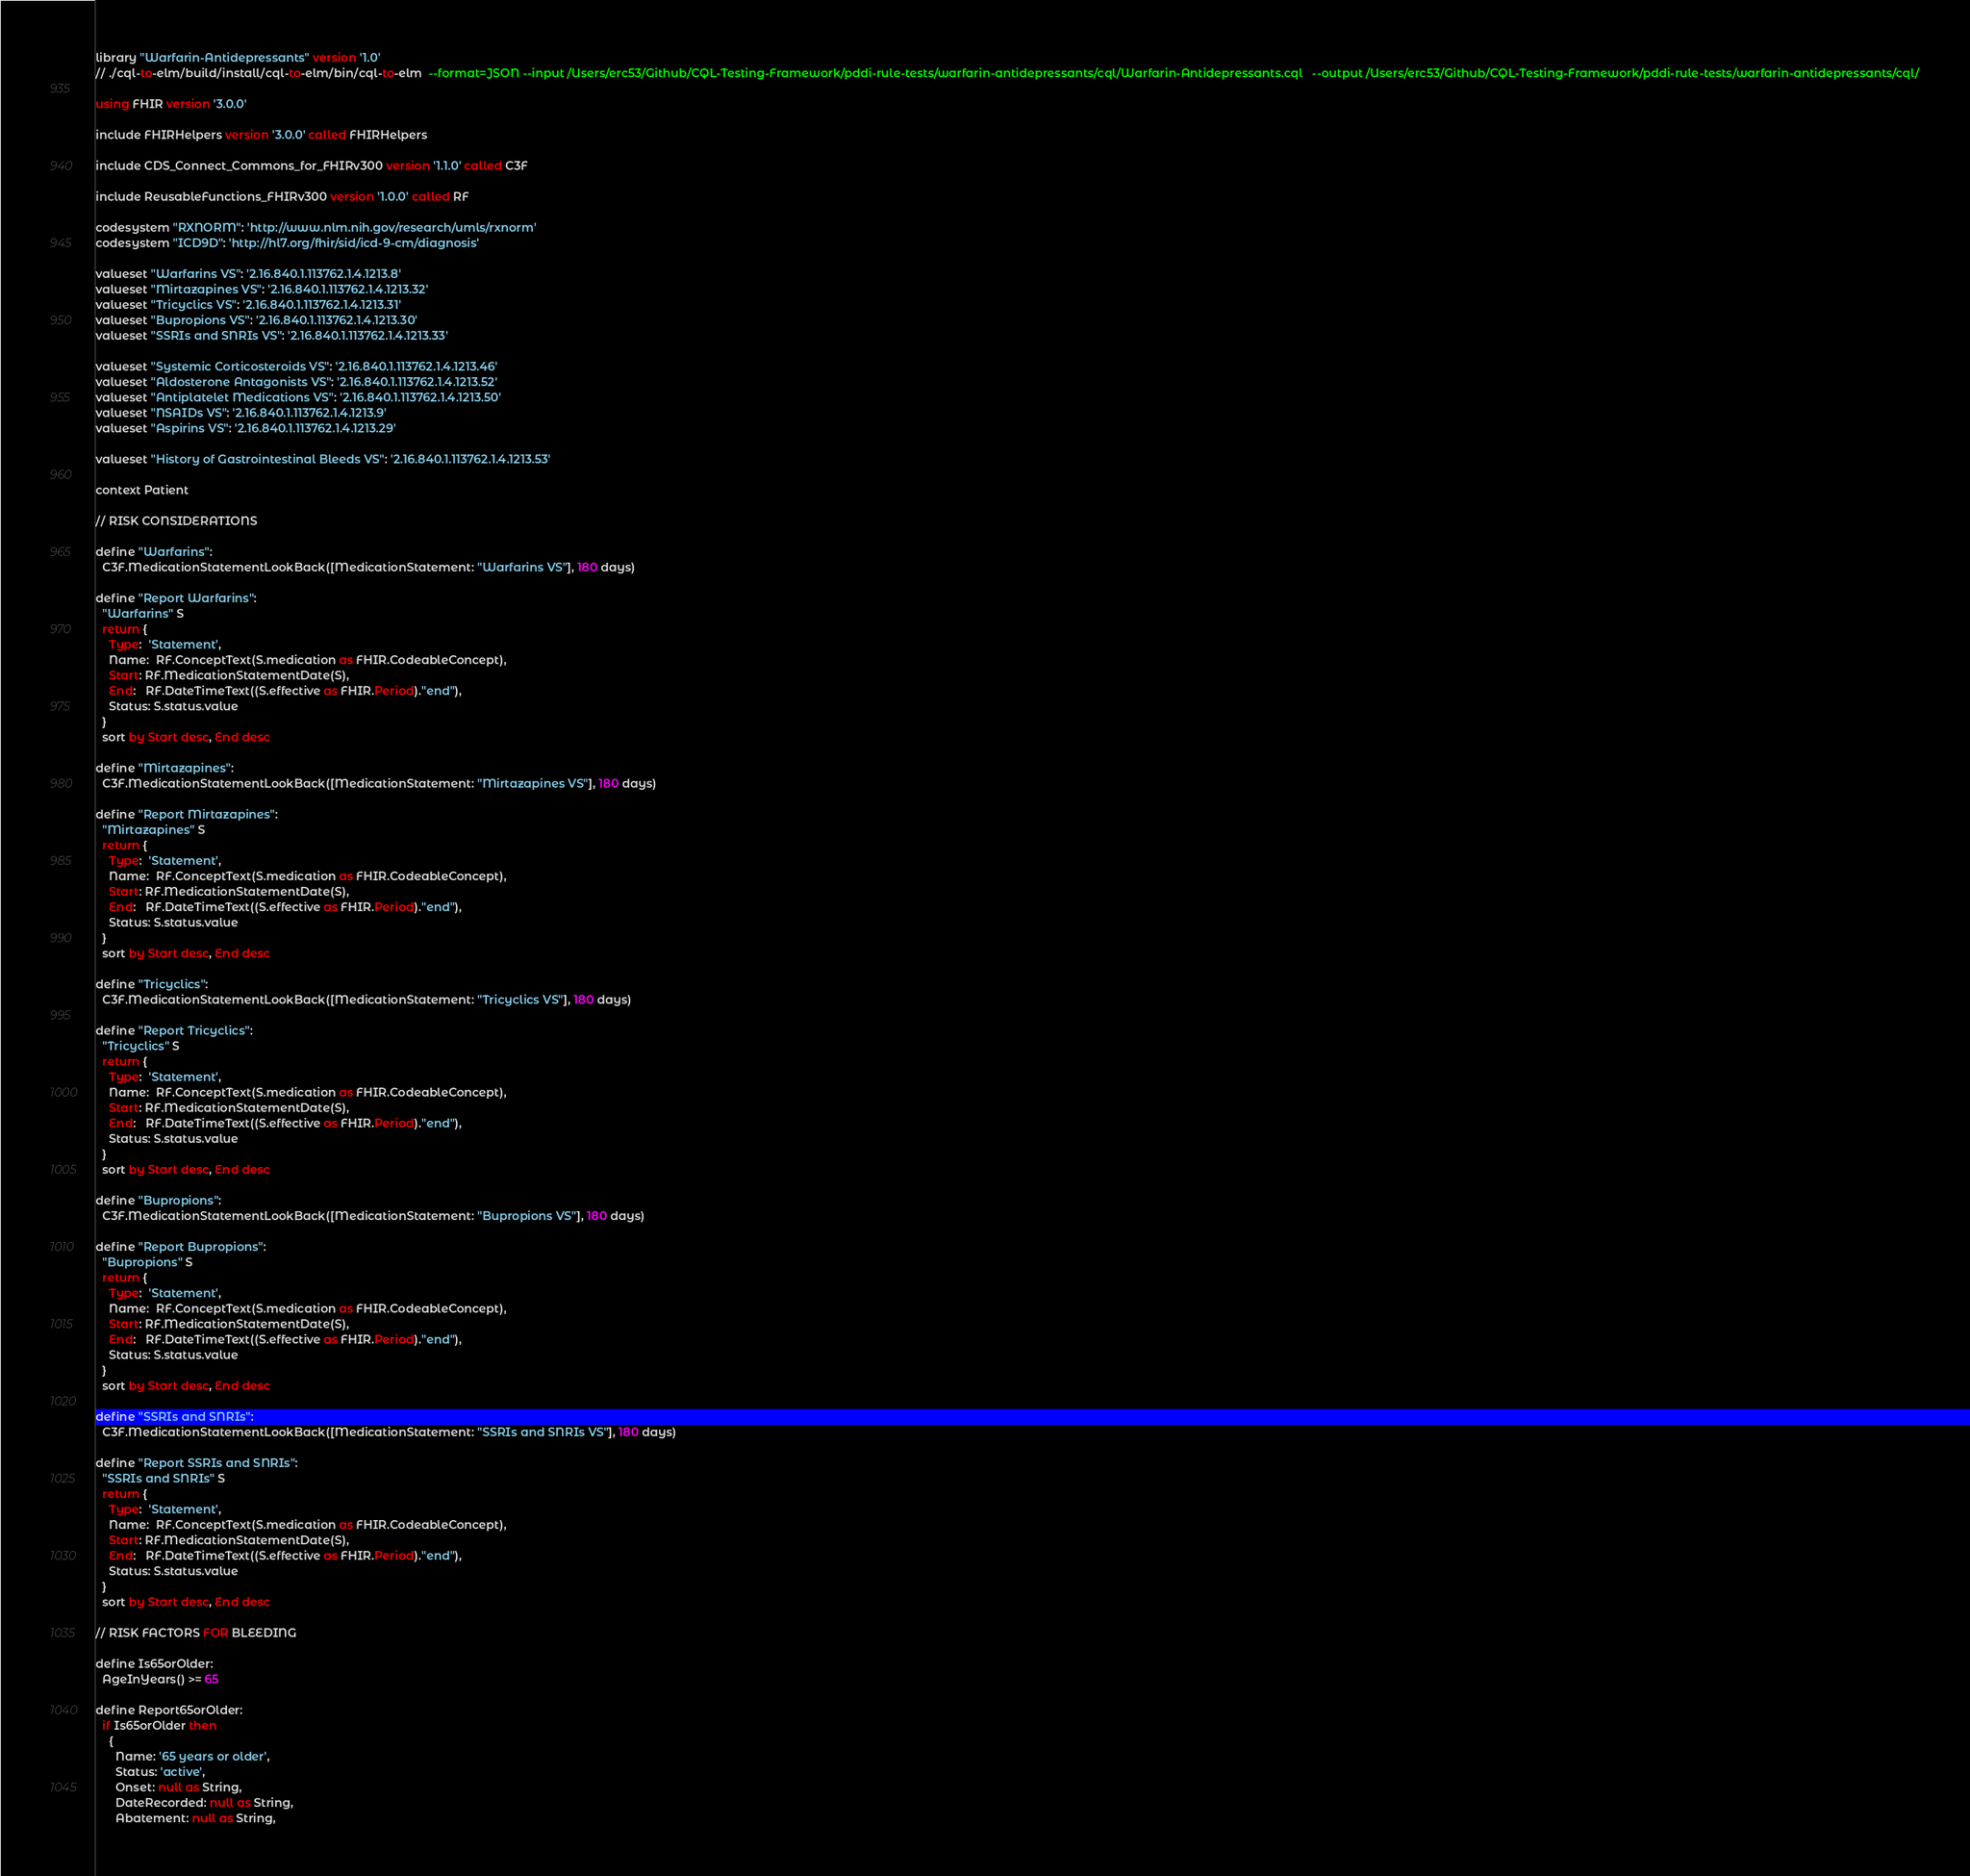<code> <loc_0><loc_0><loc_500><loc_500><_SQL_>library "Warfarin-Antidepressants" version '1.0'
// ./cql-to-elm/build/install/cql-to-elm/bin/cql-to-elm  --format=JSON --input /Users/erc53/Github/CQL-Testing-Framework/pddi-rule-tests/warfarin-antidepressants/cql/Warfarin-Antidepressants.cql   --output /Users/erc53/Github/CQL-Testing-Framework/pddi-rule-tests/warfarin-antidepressants/cql/

using FHIR version '3.0.0'

include FHIRHelpers version '3.0.0' called FHIRHelpers 

include CDS_Connect_Commons_for_FHIRv300 version '1.1.0' called C3F 

include ReusableFunctions_FHIRv300 version '1.0.0' called RF

codesystem "RXNORM": 'http://www.nlm.nih.gov/research/umls/rxnorm'
codesystem "ICD9D": 'http://hl7.org/fhir/sid/icd-9-cm/diagnosis'

valueset "Warfarins VS": '2.16.840.1.113762.1.4.1213.8'
valueset "Mirtazapines VS": '2.16.840.1.113762.1.4.1213.32'
valueset "Tricyclics VS": '2.16.840.1.113762.1.4.1213.31'
valueset "Bupropions VS": '2.16.840.1.113762.1.4.1213.30'
valueset "SSRIs and SNRIs VS": '2.16.840.1.113762.1.4.1213.33'

valueset "Systemic Corticosteroids VS": '2.16.840.1.113762.1.4.1213.46'
valueset "Aldosterone Antagonists VS": '2.16.840.1.113762.1.4.1213.52'
valueset "Antiplatelet Medications VS": '2.16.840.1.113762.1.4.1213.50'
valueset "NSAIDs VS": '2.16.840.1.113762.1.4.1213.9'
valueset "Aspirins VS": '2.16.840.1.113762.1.4.1213.29'

valueset "History of Gastrointestinal Bleeds VS": '2.16.840.1.113762.1.4.1213.53'

context Patient

// RISK CONSIDERATIONS

define "Warfarins":
  C3F.MedicationStatementLookBack([MedicationStatement: "Warfarins VS"], 180 days)

define "Report Warfarins":
  "Warfarins" S
  return {
    Type:  'Statement',
    Name:  RF.ConceptText(S.medication as FHIR.CodeableConcept),
    Start: RF.MedicationStatementDate(S),
    End:   RF.DateTimeText((S.effective as FHIR.Period)."end"),
    Status: S.status.value
  }
  sort by Start desc, End desc

define "Mirtazapines":
  C3F.MedicationStatementLookBack([MedicationStatement: "Mirtazapines VS"], 180 days)

define "Report Mirtazapines":
  "Mirtazapines" S
  return {
    Type:  'Statement',
    Name:  RF.ConceptText(S.medication as FHIR.CodeableConcept),
    Start: RF.MedicationStatementDate(S),
    End:   RF.DateTimeText((S.effective as FHIR.Period)."end"),
    Status: S.status.value
  }
  sort by Start desc, End desc

define "Tricyclics":
  C3F.MedicationStatementLookBack([MedicationStatement: "Tricyclics VS"], 180 days)

define "Report Tricyclics":
  "Tricyclics" S
  return {
    Type:  'Statement',
    Name:  RF.ConceptText(S.medication as FHIR.CodeableConcept),
    Start: RF.MedicationStatementDate(S),
    End:   RF.DateTimeText((S.effective as FHIR.Period)."end"),
    Status: S.status.value
  }
  sort by Start desc, End desc

define "Bupropions":
  C3F.MedicationStatementLookBack([MedicationStatement: "Bupropions VS"], 180 days)

define "Report Bupropions":
  "Bupropions" S
  return {
    Type:  'Statement',
    Name:  RF.ConceptText(S.medication as FHIR.CodeableConcept),
    Start: RF.MedicationStatementDate(S),
    End:   RF.DateTimeText((S.effective as FHIR.Period)."end"),
    Status: S.status.value
  }
  sort by Start desc, End desc

define "SSRIs and SNRIs":
  C3F.MedicationStatementLookBack([MedicationStatement: "SSRIs and SNRIs VS"], 180 days)

define "Report SSRIs and SNRIs":
  "SSRIs and SNRIs" S
  return {
    Type:  'Statement',
    Name:  RF.ConceptText(S.medication as FHIR.CodeableConcept),
    Start: RF.MedicationStatementDate(S),
    End:   RF.DateTimeText((S.effective as FHIR.Period)."end"),
    Status: S.status.value
  }
  sort by Start desc, End desc

// RISK FACTORS FOR BLEEDING

define Is65orOlder:
  AgeInYears() >= 65

define Report65orOlder:
  if Is65orOlder then
    {
      Name: '65 years or older',
      Status: 'active',
      Onset: null as String,
      DateRecorded: null as String,
      Abatement: null as String,</code> 